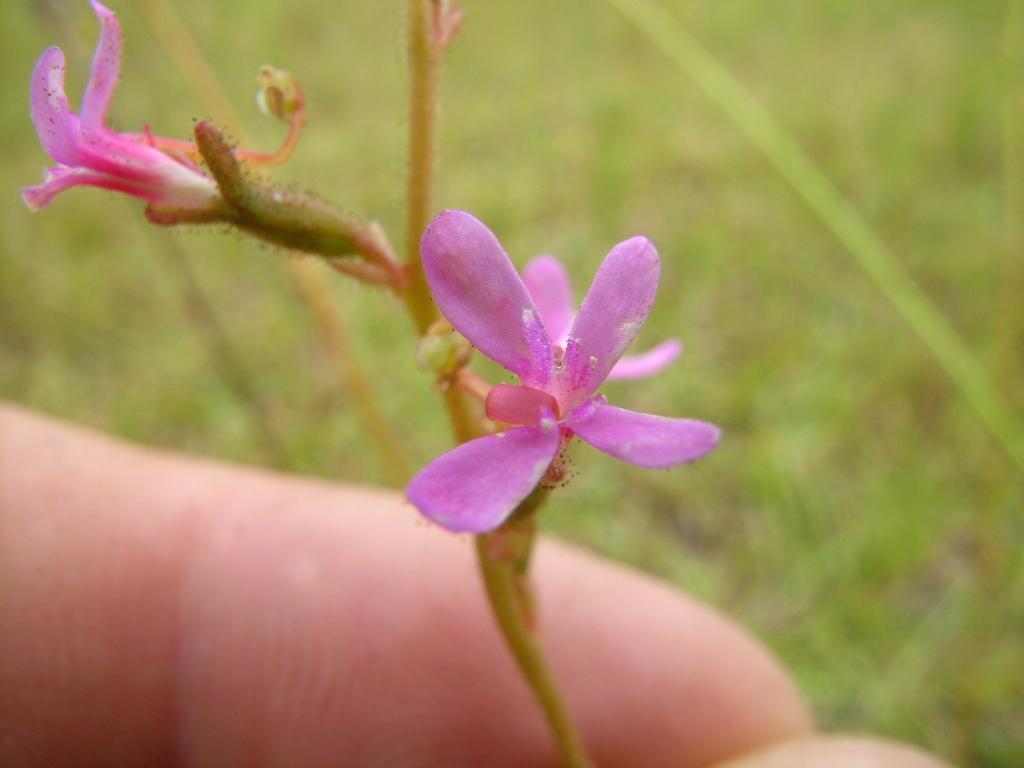Can you describe this image briefly? In this image I can see a person's hand and a tree which is green in color and to a tree I can see few flowers which are pink in color. I can see the blurry background which is green in color. 